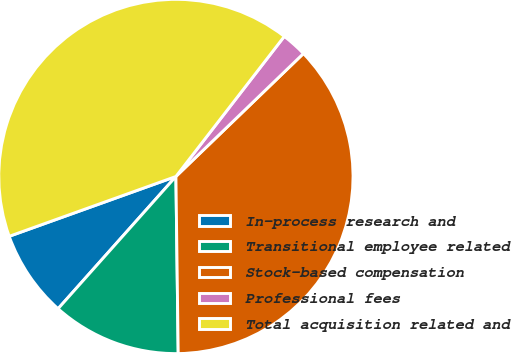<chart> <loc_0><loc_0><loc_500><loc_500><pie_chart><fcel>In-process research and<fcel>Transitional employee related<fcel>Stock-based compensation<fcel>Professional fees<fcel>Total acquisition related and<nl><fcel>7.93%<fcel>11.79%<fcel>37.0%<fcel>2.31%<fcel>40.96%<nl></chart> 